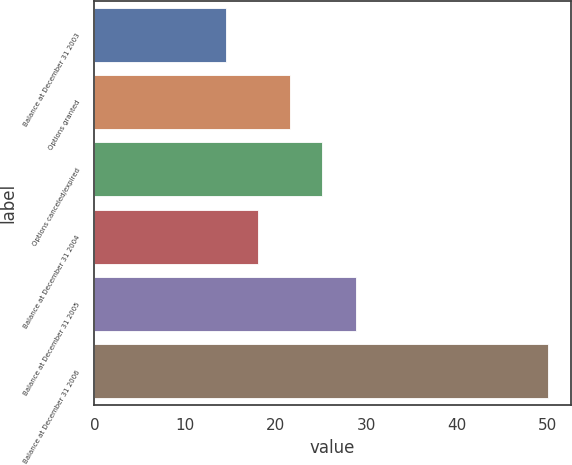Convert chart to OTSL. <chart><loc_0><loc_0><loc_500><loc_500><bar_chart><fcel>Balance at December 31 2003<fcel>Options granted<fcel>Options canceled/expired<fcel>Balance at December 31 2004<fcel>Balance at December 31 2005<fcel>Balance at December 31 2006<nl><fcel>14.5<fcel>21.62<fcel>25.18<fcel>18.06<fcel>28.93<fcel>50.1<nl></chart> 